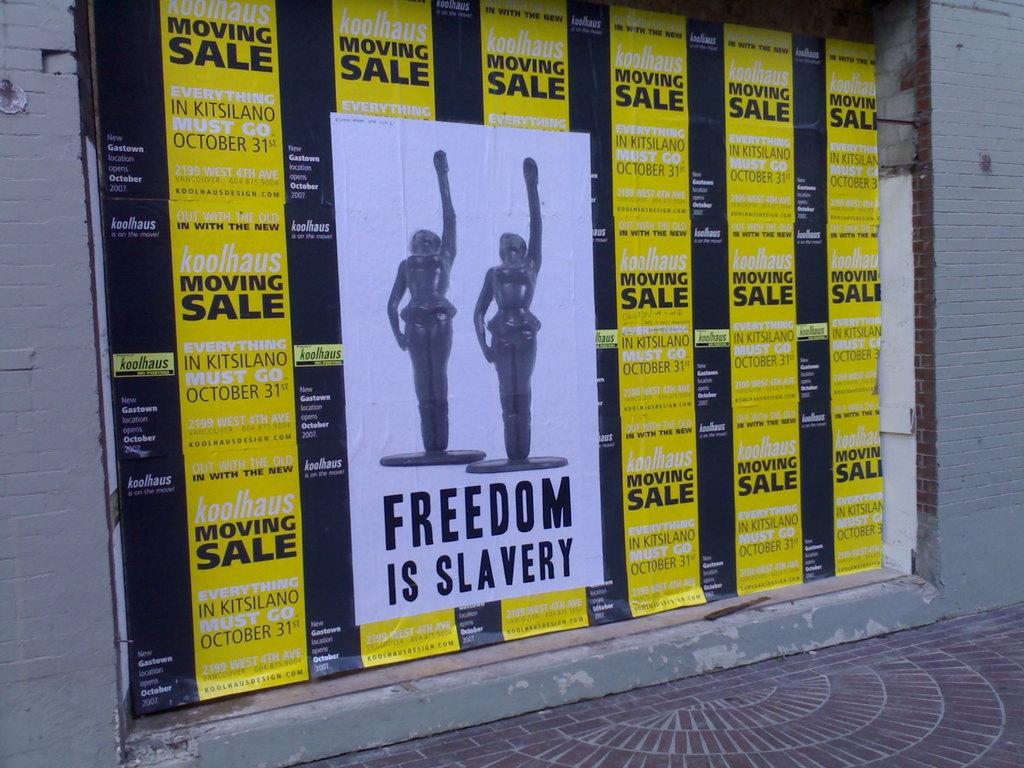<image>
Relay a brief, clear account of the picture shown. An advertisement with two women and the saying Freedom is Slavery 